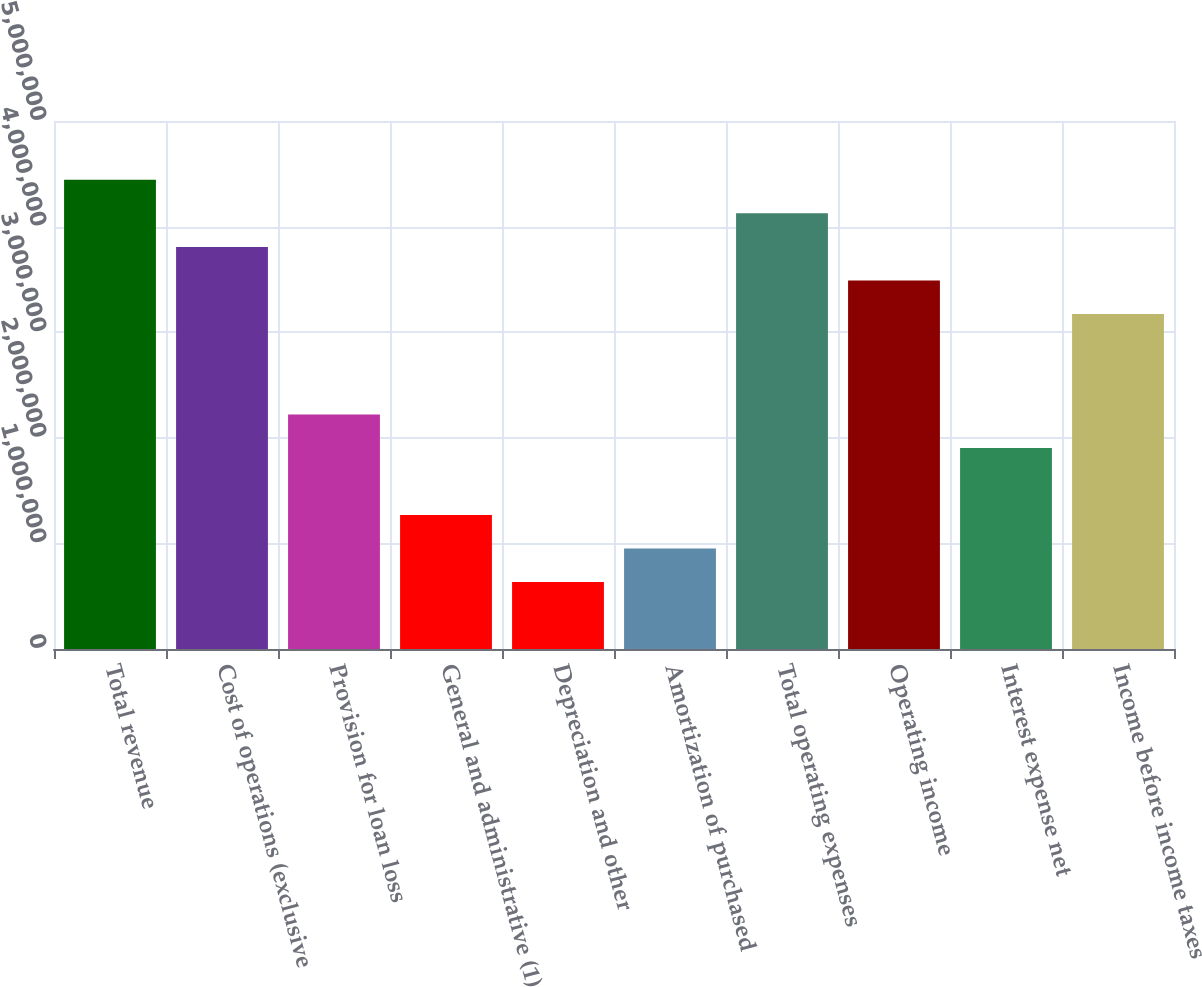Convert chart to OTSL. <chart><loc_0><loc_0><loc_500><loc_500><bar_chart><fcel>Total revenue<fcel>Cost of operations (exclusive<fcel>Provision for loan loss<fcel>General and administrative (1)<fcel>Depreciation and other<fcel>Amortization of purchased<fcel>Total operating expenses<fcel>Operating income<fcel>Interest expense net<fcel>Income before income taxes<nl><fcel>4.4426e+06<fcel>3.80794e+06<fcel>2.2213e+06<fcel>1.26932e+06<fcel>634662<fcel>951990<fcel>4.12527e+06<fcel>3.49062e+06<fcel>1.90397e+06<fcel>3.17329e+06<nl></chart> 